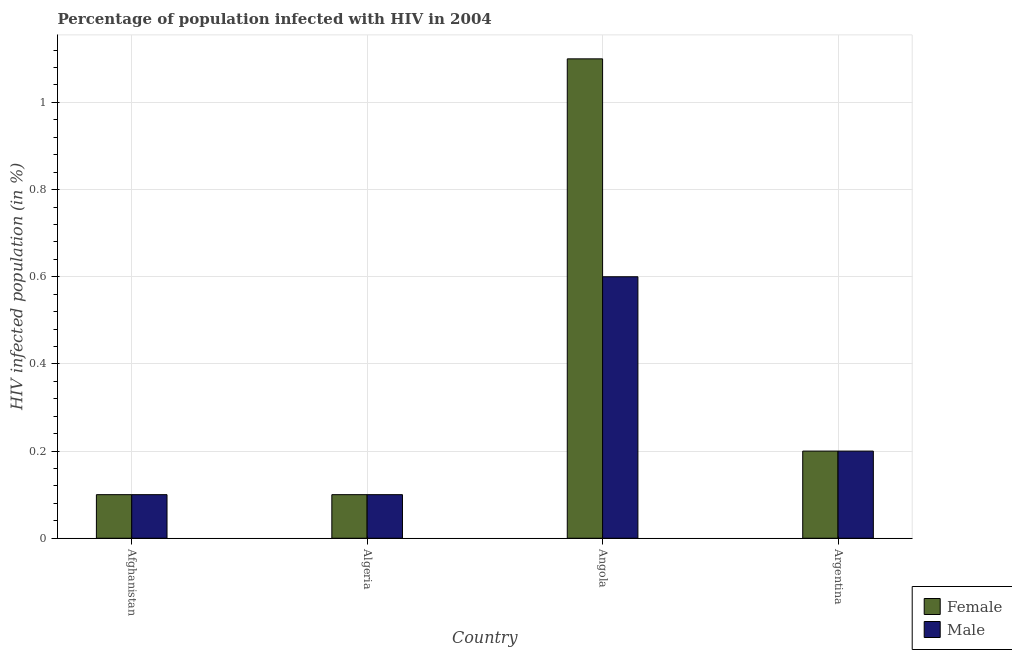How many bars are there on the 1st tick from the left?
Ensure brevity in your answer.  2. What is the label of the 2nd group of bars from the left?
Offer a terse response. Algeria. What is the percentage of males who are infected with hiv in Argentina?
Make the answer very short. 0.2. In which country was the percentage of males who are infected with hiv maximum?
Make the answer very short. Angola. In which country was the percentage of males who are infected with hiv minimum?
Provide a succinct answer. Afghanistan. What is the total percentage of females who are infected with hiv in the graph?
Provide a short and direct response. 1.5. What is the difference between the percentage of females who are infected with hiv in Angola and the percentage of males who are infected with hiv in Argentina?
Keep it short and to the point. 0.9. What is the difference between the percentage of females who are infected with hiv and percentage of males who are infected with hiv in Angola?
Offer a very short reply. 0.5. What is the ratio of the percentage of females who are infected with hiv in Afghanistan to that in Angola?
Offer a very short reply. 0.09. What is the difference between the highest and the second highest percentage of females who are infected with hiv?
Provide a succinct answer. 0.9. In how many countries, is the percentage of males who are infected with hiv greater than the average percentage of males who are infected with hiv taken over all countries?
Your response must be concise. 1. What does the 2nd bar from the left in Argentina represents?
Ensure brevity in your answer.  Male. What does the 1st bar from the right in Algeria represents?
Make the answer very short. Male. How many countries are there in the graph?
Ensure brevity in your answer.  4. Are the values on the major ticks of Y-axis written in scientific E-notation?
Ensure brevity in your answer.  No. Does the graph contain any zero values?
Provide a succinct answer. No. Does the graph contain grids?
Keep it short and to the point. Yes. How many legend labels are there?
Offer a very short reply. 2. What is the title of the graph?
Give a very brief answer. Percentage of population infected with HIV in 2004. What is the label or title of the Y-axis?
Give a very brief answer. HIV infected population (in %). What is the HIV infected population (in %) of Male in Afghanistan?
Provide a short and direct response. 0.1. What is the HIV infected population (in %) in Male in Algeria?
Provide a short and direct response. 0.1. What is the HIV infected population (in %) in Female in Angola?
Keep it short and to the point. 1.1. What is the HIV infected population (in %) of Male in Angola?
Your answer should be very brief. 0.6. What is the HIV infected population (in %) of Female in Argentina?
Your response must be concise. 0.2. Across all countries, what is the maximum HIV infected population (in %) in Female?
Offer a very short reply. 1.1. What is the total HIV infected population (in %) in Male in the graph?
Provide a succinct answer. 1. What is the difference between the HIV infected population (in %) of Female in Afghanistan and that in Angola?
Keep it short and to the point. -1. What is the difference between the HIV infected population (in %) of Male in Afghanistan and that in Angola?
Keep it short and to the point. -0.5. What is the difference between the HIV infected population (in %) of Female in Algeria and that in Angola?
Your response must be concise. -1. What is the difference between the HIV infected population (in %) in Male in Algeria and that in Angola?
Keep it short and to the point. -0.5. What is the difference between the HIV infected population (in %) of Female in Algeria and that in Argentina?
Provide a short and direct response. -0.1. What is the difference between the HIV infected population (in %) in Male in Algeria and that in Argentina?
Your response must be concise. -0.1. What is the difference between the HIV infected population (in %) of Female in Angola and that in Argentina?
Ensure brevity in your answer.  0.9. What is the difference between the HIV infected population (in %) in Female in Afghanistan and the HIV infected population (in %) in Male in Algeria?
Your response must be concise. 0. What is the difference between the HIV infected population (in %) of Female in Afghanistan and the HIV infected population (in %) of Male in Argentina?
Keep it short and to the point. -0.1. What is the average HIV infected population (in %) in Female per country?
Your answer should be compact. 0.38. What is the difference between the HIV infected population (in %) of Female and HIV infected population (in %) of Male in Algeria?
Your response must be concise. 0. What is the ratio of the HIV infected population (in %) of Male in Afghanistan to that in Algeria?
Make the answer very short. 1. What is the ratio of the HIV infected population (in %) in Female in Afghanistan to that in Angola?
Offer a very short reply. 0.09. What is the ratio of the HIV infected population (in %) in Male in Afghanistan to that in Angola?
Provide a succinct answer. 0.17. What is the ratio of the HIV infected population (in %) of Female in Afghanistan to that in Argentina?
Keep it short and to the point. 0.5. What is the ratio of the HIV infected population (in %) of Female in Algeria to that in Angola?
Your answer should be compact. 0.09. What is the ratio of the HIV infected population (in %) of Male in Algeria to that in Angola?
Provide a short and direct response. 0.17. What is the ratio of the HIV infected population (in %) in Male in Algeria to that in Argentina?
Ensure brevity in your answer.  0.5. What is the difference between the highest and the lowest HIV infected population (in %) of Male?
Provide a short and direct response. 0.5. 